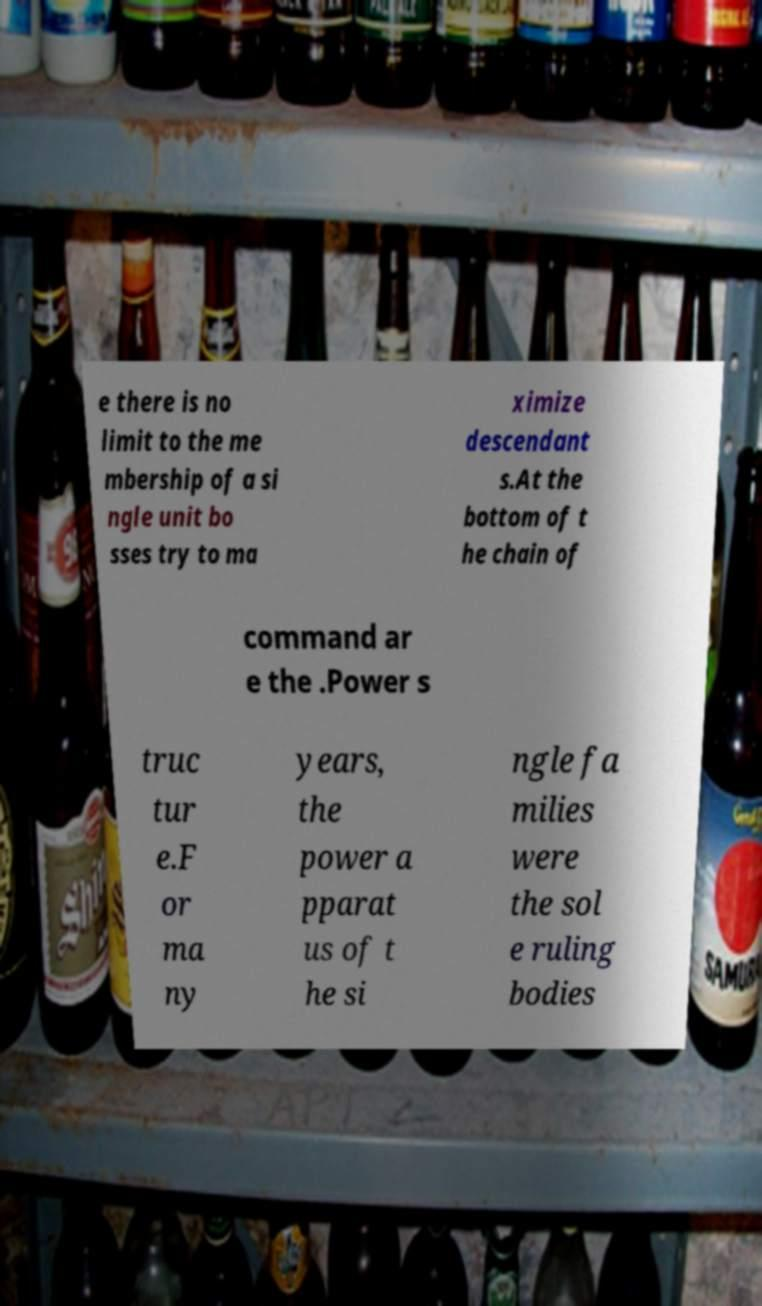There's text embedded in this image that I need extracted. Can you transcribe it verbatim? e there is no limit to the me mbership of a si ngle unit bo sses try to ma ximize descendant s.At the bottom of t he chain of command ar e the .Power s truc tur e.F or ma ny years, the power a pparat us of t he si ngle fa milies were the sol e ruling bodies 